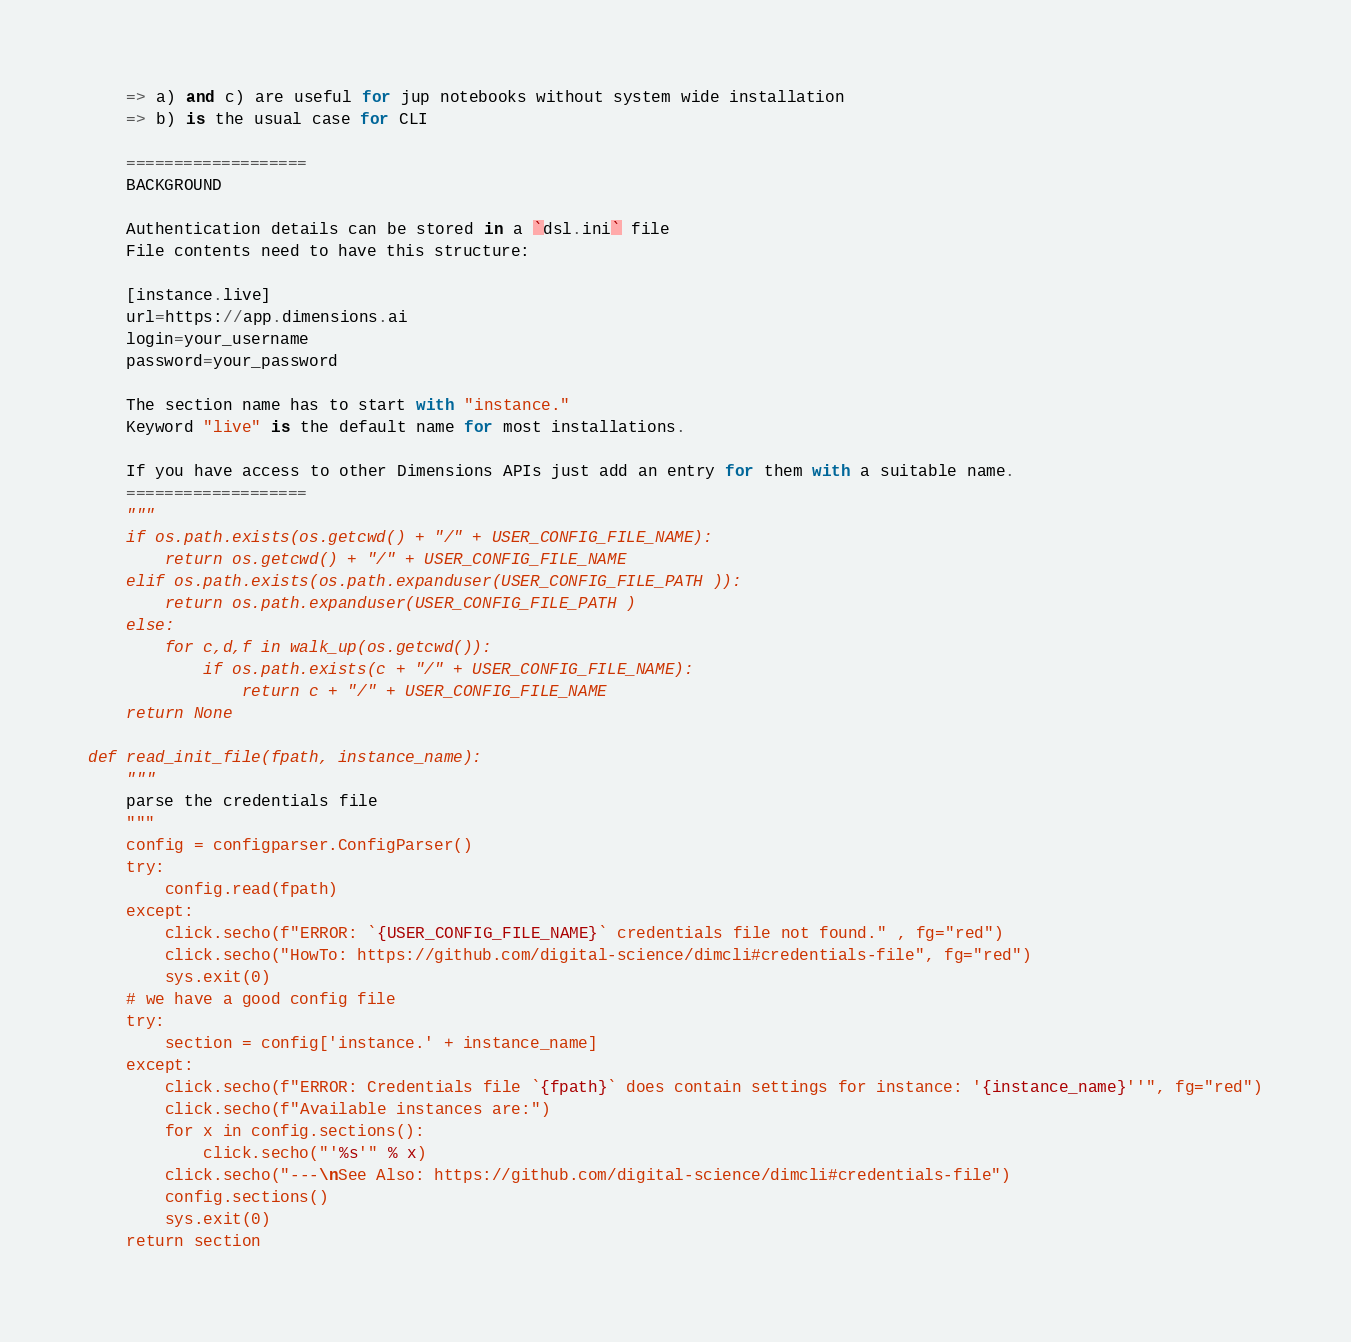Convert code to text. <code><loc_0><loc_0><loc_500><loc_500><_Python_>
    => a) and c) are useful for jup notebooks without system wide installation
    => b) is the usual case for CLI

    ===================
    BACKGROUND 

    Authentication details can be stored in a `dsl.ini` file
    File contents need to have this structure:

    [instance.live]
    url=https://app.dimensions.ai
    login=your_username
    password=your_password

    The section name has to start with "instance."
    Keyword "live" is the default name for most installations.

    If you have access to other Dimensions APIs just add an entry for them with a suitable name.
    ===================
    """
    if os.path.exists(os.getcwd() + "/" + USER_CONFIG_FILE_NAME):
        return os.getcwd() + "/" + USER_CONFIG_FILE_NAME
    elif os.path.exists(os.path.expanduser(USER_CONFIG_FILE_PATH )):
        return os.path.expanduser(USER_CONFIG_FILE_PATH )
    else:
        for c,d,f in walk_up(os.getcwd()):
            if os.path.exists(c + "/" + USER_CONFIG_FILE_NAME):
                return c + "/" + USER_CONFIG_FILE_NAME
    return None

def read_init_file(fpath, instance_name):
    """
    parse the credentials file
    """
    config = configparser.ConfigParser()
    try:
        config.read(fpath)
    except:
        click.secho(f"ERROR: `{USER_CONFIG_FILE_NAME}` credentials file not found." , fg="red")
        click.secho("HowTo: https://github.com/digital-science/dimcli#credentials-file", fg="red")
        sys.exit(0)
    # we have a good config file
    try:
        section = config['instance.' + instance_name]
    except:
        click.secho(f"ERROR: Credentials file `{fpath}` does contain settings for instance: '{instance_name}''", fg="red")
        click.secho(f"Available instances are:")
        for x in config.sections():
            click.secho("'%s'" % x)
        click.secho("---\nSee Also: https://github.com/digital-science/dimcli#credentials-file")
        config.sections()
        sys.exit(0)
    return section


</code> 